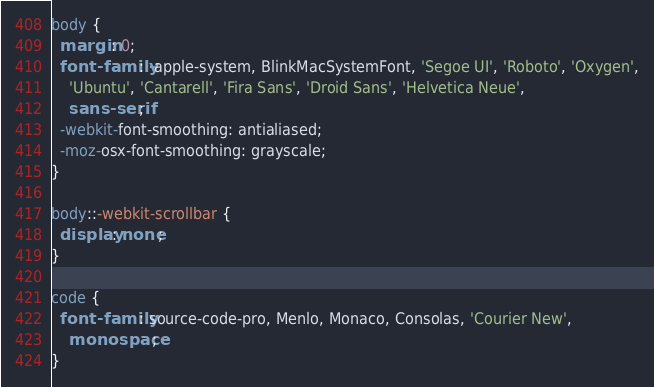<code> <loc_0><loc_0><loc_500><loc_500><_CSS_>body {
  margin: 0;
  font-family: -apple-system, BlinkMacSystemFont, 'Segoe UI', 'Roboto', 'Oxygen',
    'Ubuntu', 'Cantarell', 'Fira Sans', 'Droid Sans', 'Helvetica Neue',
    sans-serif;
  -webkit-font-smoothing: antialiased;
  -moz-osx-font-smoothing: grayscale;
}

body::-webkit-scrollbar {
  display: none;
}

code {
  font-family: source-code-pro, Menlo, Monaco, Consolas, 'Courier New',
    monospace;
}
</code> 